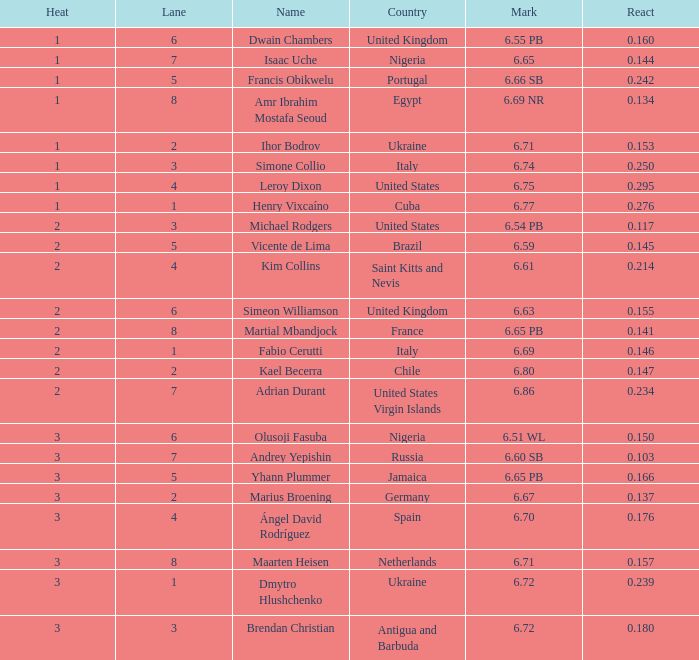166? Portugal. 